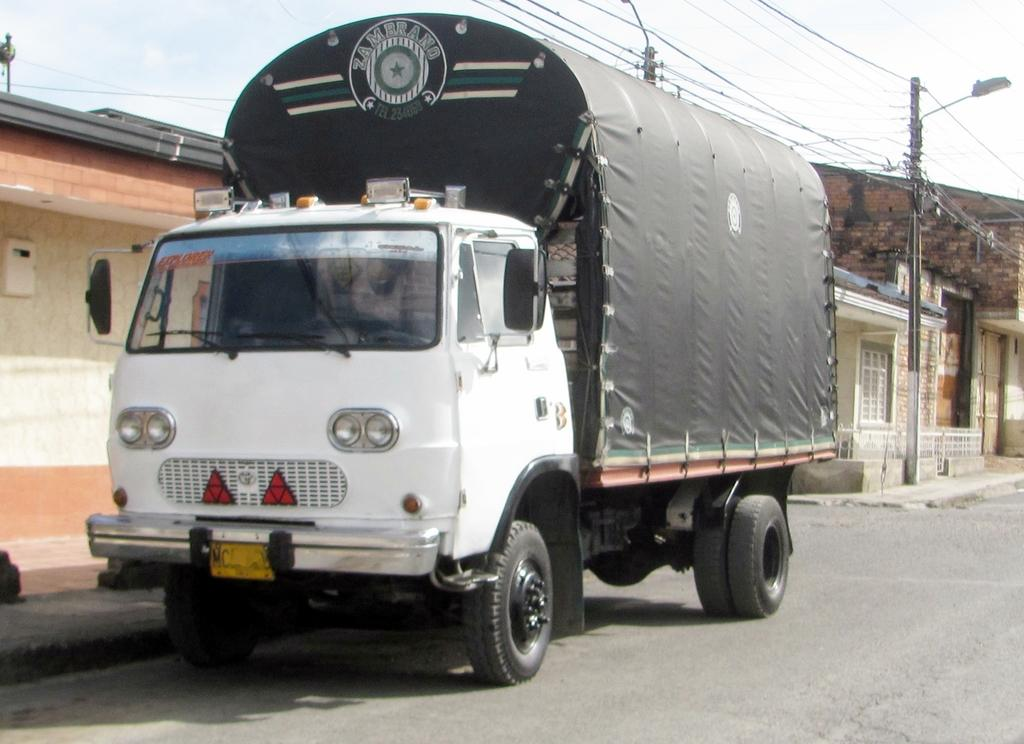What type of vehicle is on the road in the image? There is a lorry on the road in the image. What can be seen on the side of the road? There are two electric poles on the side of the road. What is located on the right side of the image? There are houses on the right side of the image. What is visible in the sky in the image? There are clouds visible in the sky. What type of watch is the lorry driver wearing in the image? There is no information about the lorry driver or any watches in the image. 